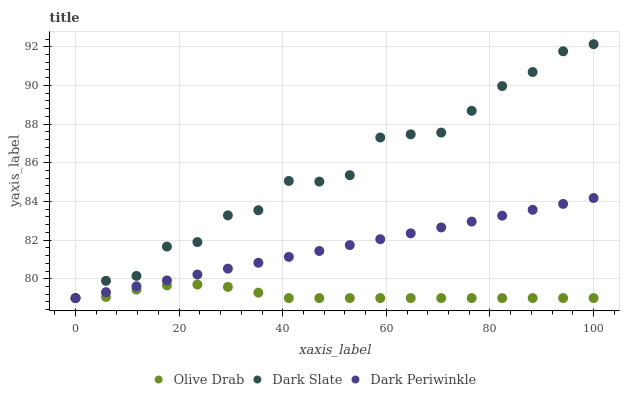Does Olive Drab have the minimum area under the curve?
Answer yes or no. Yes. Does Dark Slate have the maximum area under the curve?
Answer yes or no. Yes. Does Dark Periwinkle have the minimum area under the curve?
Answer yes or no. No. Does Dark Periwinkle have the maximum area under the curve?
Answer yes or no. No. Is Dark Periwinkle the smoothest?
Answer yes or no. Yes. Is Dark Slate the roughest?
Answer yes or no. Yes. Is Olive Drab the smoothest?
Answer yes or no. No. Is Olive Drab the roughest?
Answer yes or no. No. Does Dark Slate have the lowest value?
Answer yes or no. Yes. Does Dark Slate have the highest value?
Answer yes or no. Yes. Does Dark Periwinkle have the highest value?
Answer yes or no. No. Does Dark Slate intersect Dark Periwinkle?
Answer yes or no. Yes. Is Dark Slate less than Dark Periwinkle?
Answer yes or no. No. Is Dark Slate greater than Dark Periwinkle?
Answer yes or no. No. 